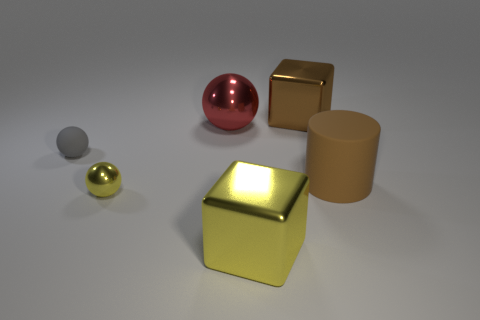Add 2 rubber cylinders. How many objects exist? 8 Subtract all cubes. How many objects are left? 4 Add 4 metal things. How many metal things are left? 8 Add 4 rubber cylinders. How many rubber cylinders exist? 5 Subtract 0 purple balls. How many objects are left? 6 Subtract all blue blocks. Subtract all tiny yellow balls. How many objects are left? 5 